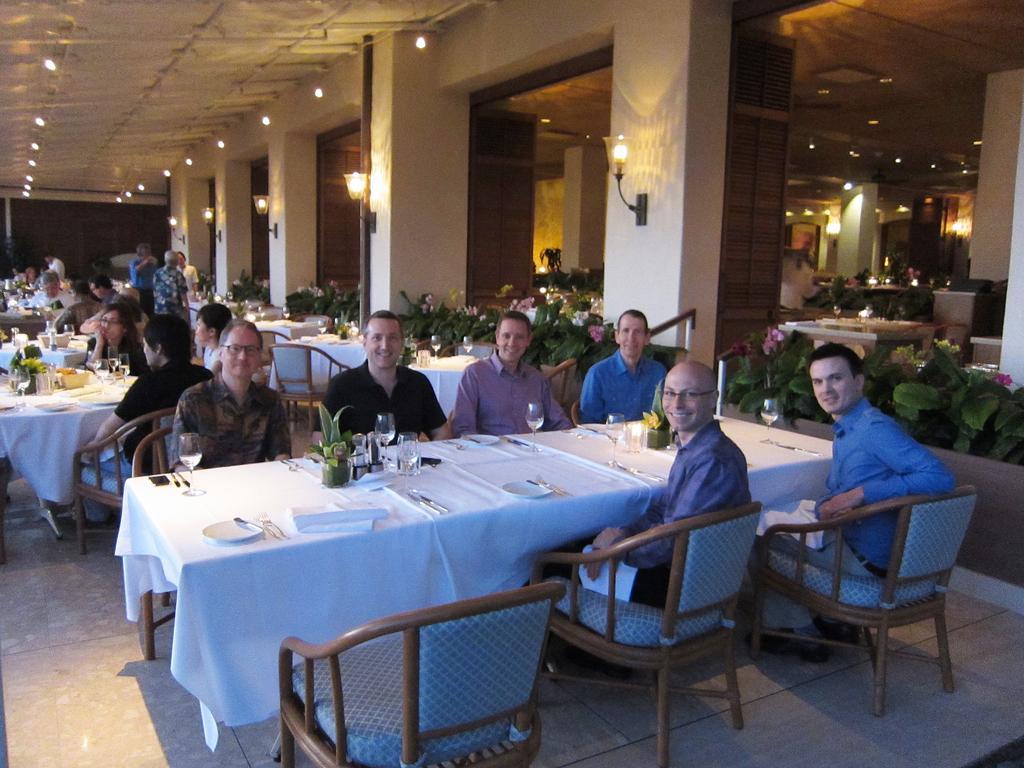In one or two sentences, can you explain what this image depicts? there are many tables and chairs placed in a room. on the table there are glasses, plates. at the right there are plants and lights. 